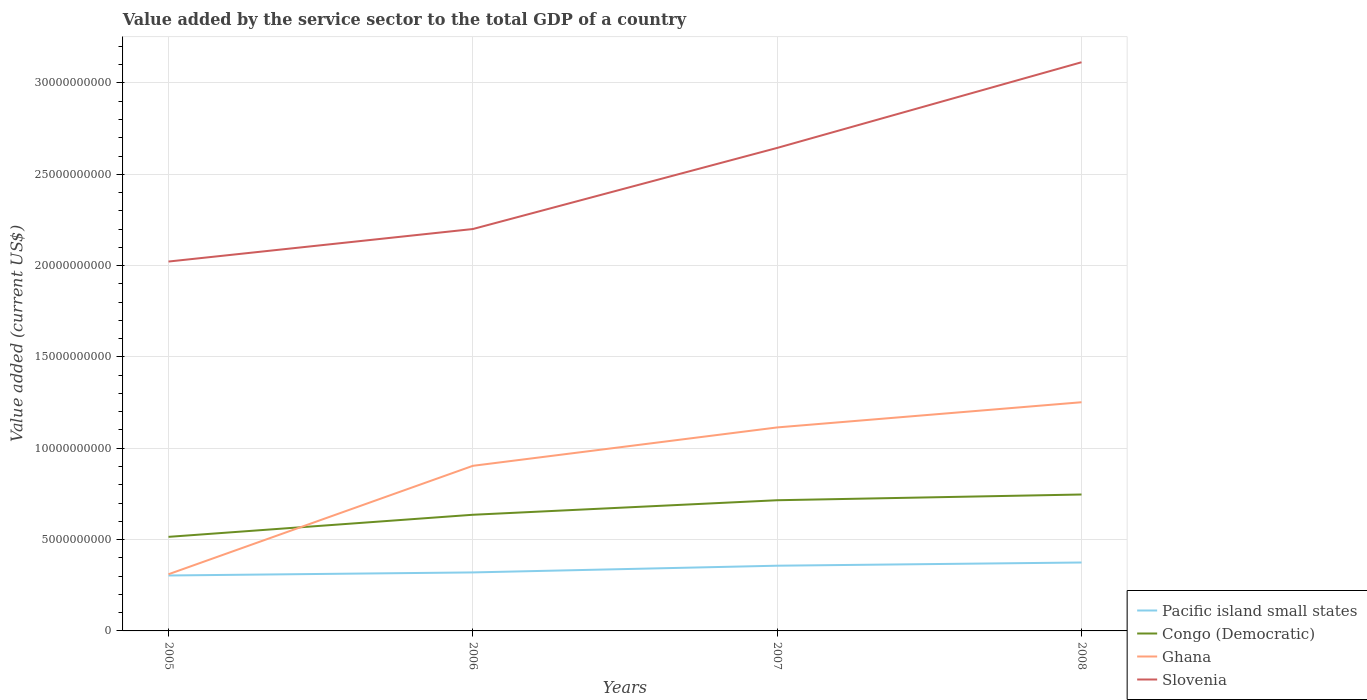Is the number of lines equal to the number of legend labels?
Your response must be concise. Yes. Across all years, what is the maximum value added by the service sector to the total GDP in Congo (Democratic)?
Ensure brevity in your answer.  5.15e+09. In which year was the value added by the service sector to the total GDP in Ghana maximum?
Provide a short and direct response. 2005. What is the total value added by the service sector to the total GDP in Pacific island small states in the graph?
Offer a terse response. -3.68e+08. What is the difference between the highest and the second highest value added by the service sector to the total GDP in Ghana?
Your answer should be compact. 9.42e+09. Is the value added by the service sector to the total GDP in Congo (Democratic) strictly greater than the value added by the service sector to the total GDP in Pacific island small states over the years?
Your response must be concise. No. How many years are there in the graph?
Ensure brevity in your answer.  4. Are the values on the major ticks of Y-axis written in scientific E-notation?
Make the answer very short. No. Does the graph contain any zero values?
Provide a short and direct response. No. Does the graph contain grids?
Offer a terse response. Yes. Where does the legend appear in the graph?
Ensure brevity in your answer.  Bottom right. How many legend labels are there?
Keep it short and to the point. 4. How are the legend labels stacked?
Your response must be concise. Vertical. What is the title of the graph?
Your answer should be compact. Value added by the service sector to the total GDP of a country. Does "Jamaica" appear as one of the legend labels in the graph?
Give a very brief answer. No. What is the label or title of the X-axis?
Give a very brief answer. Years. What is the label or title of the Y-axis?
Keep it short and to the point. Value added (current US$). What is the Value added (current US$) in Pacific island small states in 2005?
Offer a very short reply. 3.03e+09. What is the Value added (current US$) of Congo (Democratic) in 2005?
Make the answer very short. 5.15e+09. What is the Value added (current US$) in Ghana in 2005?
Offer a terse response. 3.10e+09. What is the Value added (current US$) of Slovenia in 2005?
Offer a very short reply. 2.02e+1. What is the Value added (current US$) in Pacific island small states in 2006?
Your answer should be very brief. 3.20e+09. What is the Value added (current US$) in Congo (Democratic) in 2006?
Keep it short and to the point. 6.36e+09. What is the Value added (current US$) of Ghana in 2006?
Your answer should be compact. 9.04e+09. What is the Value added (current US$) of Slovenia in 2006?
Ensure brevity in your answer.  2.20e+1. What is the Value added (current US$) of Pacific island small states in 2007?
Offer a terse response. 3.57e+09. What is the Value added (current US$) of Congo (Democratic) in 2007?
Provide a succinct answer. 7.15e+09. What is the Value added (current US$) in Ghana in 2007?
Give a very brief answer. 1.11e+1. What is the Value added (current US$) in Slovenia in 2007?
Ensure brevity in your answer.  2.64e+1. What is the Value added (current US$) in Pacific island small states in 2008?
Provide a short and direct response. 3.75e+09. What is the Value added (current US$) in Congo (Democratic) in 2008?
Your response must be concise. 7.47e+09. What is the Value added (current US$) in Ghana in 2008?
Provide a succinct answer. 1.25e+1. What is the Value added (current US$) of Slovenia in 2008?
Your answer should be compact. 3.11e+1. Across all years, what is the maximum Value added (current US$) of Pacific island small states?
Ensure brevity in your answer.  3.75e+09. Across all years, what is the maximum Value added (current US$) of Congo (Democratic)?
Offer a very short reply. 7.47e+09. Across all years, what is the maximum Value added (current US$) of Ghana?
Offer a very short reply. 1.25e+1. Across all years, what is the maximum Value added (current US$) of Slovenia?
Keep it short and to the point. 3.11e+1. Across all years, what is the minimum Value added (current US$) of Pacific island small states?
Make the answer very short. 3.03e+09. Across all years, what is the minimum Value added (current US$) of Congo (Democratic)?
Give a very brief answer. 5.15e+09. Across all years, what is the minimum Value added (current US$) in Ghana?
Your response must be concise. 3.10e+09. Across all years, what is the minimum Value added (current US$) of Slovenia?
Provide a succinct answer. 2.02e+1. What is the total Value added (current US$) of Pacific island small states in the graph?
Ensure brevity in your answer.  1.36e+1. What is the total Value added (current US$) of Congo (Democratic) in the graph?
Ensure brevity in your answer.  2.61e+1. What is the total Value added (current US$) in Ghana in the graph?
Make the answer very short. 3.58e+1. What is the total Value added (current US$) of Slovenia in the graph?
Your answer should be very brief. 9.98e+1. What is the difference between the Value added (current US$) in Pacific island small states in 2005 and that in 2006?
Provide a short and direct response. -1.68e+08. What is the difference between the Value added (current US$) in Congo (Democratic) in 2005 and that in 2006?
Provide a succinct answer. -1.21e+09. What is the difference between the Value added (current US$) in Ghana in 2005 and that in 2006?
Ensure brevity in your answer.  -5.94e+09. What is the difference between the Value added (current US$) in Slovenia in 2005 and that in 2006?
Offer a terse response. -1.78e+09. What is the difference between the Value added (current US$) of Pacific island small states in 2005 and that in 2007?
Your answer should be compact. -5.36e+08. What is the difference between the Value added (current US$) of Congo (Democratic) in 2005 and that in 2007?
Make the answer very short. -2.00e+09. What is the difference between the Value added (current US$) of Ghana in 2005 and that in 2007?
Make the answer very short. -8.04e+09. What is the difference between the Value added (current US$) of Slovenia in 2005 and that in 2007?
Offer a very short reply. -6.22e+09. What is the difference between the Value added (current US$) in Pacific island small states in 2005 and that in 2008?
Make the answer very short. -7.11e+08. What is the difference between the Value added (current US$) of Congo (Democratic) in 2005 and that in 2008?
Your answer should be compact. -2.32e+09. What is the difference between the Value added (current US$) in Ghana in 2005 and that in 2008?
Provide a short and direct response. -9.42e+09. What is the difference between the Value added (current US$) in Slovenia in 2005 and that in 2008?
Provide a short and direct response. -1.09e+1. What is the difference between the Value added (current US$) in Pacific island small states in 2006 and that in 2007?
Give a very brief answer. -3.68e+08. What is the difference between the Value added (current US$) in Congo (Democratic) in 2006 and that in 2007?
Ensure brevity in your answer.  -7.95e+08. What is the difference between the Value added (current US$) of Ghana in 2006 and that in 2007?
Provide a short and direct response. -2.10e+09. What is the difference between the Value added (current US$) of Slovenia in 2006 and that in 2007?
Your answer should be compact. -4.44e+09. What is the difference between the Value added (current US$) of Pacific island small states in 2006 and that in 2008?
Offer a terse response. -5.43e+08. What is the difference between the Value added (current US$) in Congo (Democratic) in 2006 and that in 2008?
Give a very brief answer. -1.11e+09. What is the difference between the Value added (current US$) in Ghana in 2006 and that in 2008?
Give a very brief answer. -3.48e+09. What is the difference between the Value added (current US$) in Slovenia in 2006 and that in 2008?
Offer a terse response. -9.13e+09. What is the difference between the Value added (current US$) of Pacific island small states in 2007 and that in 2008?
Your answer should be compact. -1.75e+08. What is the difference between the Value added (current US$) of Congo (Democratic) in 2007 and that in 2008?
Make the answer very short. -3.14e+08. What is the difference between the Value added (current US$) of Ghana in 2007 and that in 2008?
Give a very brief answer. -1.38e+09. What is the difference between the Value added (current US$) of Slovenia in 2007 and that in 2008?
Your answer should be very brief. -4.69e+09. What is the difference between the Value added (current US$) in Pacific island small states in 2005 and the Value added (current US$) in Congo (Democratic) in 2006?
Make the answer very short. -3.32e+09. What is the difference between the Value added (current US$) of Pacific island small states in 2005 and the Value added (current US$) of Ghana in 2006?
Provide a succinct answer. -6.00e+09. What is the difference between the Value added (current US$) in Pacific island small states in 2005 and the Value added (current US$) in Slovenia in 2006?
Your answer should be compact. -1.90e+1. What is the difference between the Value added (current US$) of Congo (Democratic) in 2005 and the Value added (current US$) of Ghana in 2006?
Keep it short and to the point. -3.89e+09. What is the difference between the Value added (current US$) in Congo (Democratic) in 2005 and the Value added (current US$) in Slovenia in 2006?
Offer a very short reply. -1.69e+1. What is the difference between the Value added (current US$) of Ghana in 2005 and the Value added (current US$) of Slovenia in 2006?
Offer a very short reply. -1.89e+1. What is the difference between the Value added (current US$) in Pacific island small states in 2005 and the Value added (current US$) in Congo (Democratic) in 2007?
Your answer should be compact. -4.12e+09. What is the difference between the Value added (current US$) of Pacific island small states in 2005 and the Value added (current US$) of Ghana in 2007?
Your answer should be very brief. -8.11e+09. What is the difference between the Value added (current US$) of Pacific island small states in 2005 and the Value added (current US$) of Slovenia in 2007?
Offer a terse response. -2.34e+1. What is the difference between the Value added (current US$) in Congo (Democratic) in 2005 and the Value added (current US$) in Ghana in 2007?
Your response must be concise. -5.99e+09. What is the difference between the Value added (current US$) of Congo (Democratic) in 2005 and the Value added (current US$) of Slovenia in 2007?
Your answer should be very brief. -2.13e+1. What is the difference between the Value added (current US$) in Ghana in 2005 and the Value added (current US$) in Slovenia in 2007?
Offer a terse response. -2.33e+1. What is the difference between the Value added (current US$) in Pacific island small states in 2005 and the Value added (current US$) in Congo (Democratic) in 2008?
Your answer should be compact. -4.43e+09. What is the difference between the Value added (current US$) of Pacific island small states in 2005 and the Value added (current US$) of Ghana in 2008?
Provide a short and direct response. -9.49e+09. What is the difference between the Value added (current US$) of Pacific island small states in 2005 and the Value added (current US$) of Slovenia in 2008?
Make the answer very short. -2.81e+1. What is the difference between the Value added (current US$) of Congo (Democratic) in 2005 and the Value added (current US$) of Ghana in 2008?
Keep it short and to the point. -7.37e+09. What is the difference between the Value added (current US$) in Congo (Democratic) in 2005 and the Value added (current US$) in Slovenia in 2008?
Give a very brief answer. -2.60e+1. What is the difference between the Value added (current US$) of Ghana in 2005 and the Value added (current US$) of Slovenia in 2008?
Give a very brief answer. -2.80e+1. What is the difference between the Value added (current US$) of Pacific island small states in 2006 and the Value added (current US$) of Congo (Democratic) in 2007?
Keep it short and to the point. -3.95e+09. What is the difference between the Value added (current US$) of Pacific island small states in 2006 and the Value added (current US$) of Ghana in 2007?
Your answer should be very brief. -7.94e+09. What is the difference between the Value added (current US$) of Pacific island small states in 2006 and the Value added (current US$) of Slovenia in 2007?
Ensure brevity in your answer.  -2.32e+1. What is the difference between the Value added (current US$) in Congo (Democratic) in 2006 and the Value added (current US$) in Ghana in 2007?
Your answer should be very brief. -4.78e+09. What is the difference between the Value added (current US$) in Congo (Democratic) in 2006 and the Value added (current US$) in Slovenia in 2007?
Your answer should be very brief. -2.01e+1. What is the difference between the Value added (current US$) in Ghana in 2006 and the Value added (current US$) in Slovenia in 2007?
Ensure brevity in your answer.  -1.74e+1. What is the difference between the Value added (current US$) in Pacific island small states in 2006 and the Value added (current US$) in Congo (Democratic) in 2008?
Ensure brevity in your answer.  -4.27e+09. What is the difference between the Value added (current US$) in Pacific island small states in 2006 and the Value added (current US$) in Ghana in 2008?
Your answer should be compact. -9.32e+09. What is the difference between the Value added (current US$) in Pacific island small states in 2006 and the Value added (current US$) in Slovenia in 2008?
Your answer should be compact. -2.79e+1. What is the difference between the Value added (current US$) in Congo (Democratic) in 2006 and the Value added (current US$) in Ghana in 2008?
Offer a terse response. -6.16e+09. What is the difference between the Value added (current US$) of Congo (Democratic) in 2006 and the Value added (current US$) of Slovenia in 2008?
Your answer should be very brief. -2.48e+1. What is the difference between the Value added (current US$) of Ghana in 2006 and the Value added (current US$) of Slovenia in 2008?
Provide a short and direct response. -2.21e+1. What is the difference between the Value added (current US$) in Pacific island small states in 2007 and the Value added (current US$) in Congo (Democratic) in 2008?
Your answer should be compact. -3.90e+09. What is the difference between the Value added (current US$) of Pacific island small states in 2007 and the Value added (current US$) of Ghana in 2008?
Your response must be concise. -8.95e+09. What is the difference between the Value added (current US$) in Pacific island small states in 2007 and the Value added (current US$) in Slovenia in 2008?
Your answer should be compact. -2.76e+1. What is the difference between the Value added (current US$) of Congo (Democratic) in 2007 and the Value added (current US$) of Ghana in 2008?
Provide a succinct answer. -5.37e+09. What is the difference between the Value added (current US$) of Congo (Democratic) in 2007 and the Value added (current US$) of Slovenia in 2008?
Provide a short and direct response. -2.40e+1. What is the difference between the Value added (current US$) in Ghana in 2007 and the Value added (current US$) in Slovenia in 2008?
Offer a terse response. -2.00e+1. What is the average Value added (current US$) of Pacific island small states per year?
Your answer should be very brief. 3.39e+09. What is the average Value added (current US$) of Congo (Democratic) per year?
Your answer should be compact. 6.53e+09. What is the average Value added (current US$) of Ghana per year?
Ensure brevity in your answer.  8.95e+09. What is the average Value added (current US$) in Slovenia per year?
Keep it short and to the point. 2.50e+1. In the year 2005, what is the difference between the Value added (current US$) in Pacific island small states and Value added (current US$) in Congo (Democratic)?
Your response must be concise. -2.12e+09. In the year 2005, what is the difference between the Value added (current US$) of Pacific island small states and Value added (current US$) of Ghana?
Your answer should be very brief. -6.82e+07. In the year 2005, what is the difference between the Value added (current US$) of Pacific island small states and Value added (current US$) of Slovenia?
Provide a short and direct response. -1.72e+1. In the year 2005, what is the difference between the Value added (current US$) in Congo (Democratic) and Value added (current US$) in Ghana?
Keep it short and to the point. 2.05e+09. In the year 2005, what is the difference between the Value added (current US$) of Congo (Democratic) and Value added (current US$) of Slovenia?
Provide a succinct answer. -1.51e+1. In the year 2005, what is the difference between the Value added (current US$) of Ghana and Value added (current US$) of Slovenia?
Ensure brevity in your answer.  -1.71e+1. In the year 2006, what is the difference between the Value added (current US$) of Pacific island small states and Value added (current US$) of Congo (Democratic)?
Keep it short and to the point. -3.16e+09. In the year 2006, what is the difference between the Value added (current US$) in Pacific island small states and Value added (current US$) in Ghana?
Ensure brevity in your answer.  -5.84e+09. In the year 2006, what is the difference between the Value added (current US$) of Pacific island small states and Value added (current US$) of Slovenia?
Offer a terse response. -1.88e+1. In the year 2006, what is the difference between the Value added (current US$) of Congo (Democratic) and Value added (current US$) of Ghana?
Offer a very short reply. -2.68e+09. In the year 2006, what is the difference between the Value added (current US$) of Congo (Democratic) and Value added (current US$) of Slovenia?
Ensure brevity in your answer.  -1.56e+1. In the year 2006, what is the difference between the Value added (current US$) of Ghana and Value added (current US$) of Slovenia?
Ensure brevity in your answer.  -1.30e+1. In the year 2007, what is the difference between the Value added (current US$) of Pacific island small states and Value added (current US$) of Congo (Democratic)?
Give a very brief answer. -3.58e+09. In the year 2007, what is the difference between the Value added (current US$) of Pacific island small states and Value added (current US$) of Ghana?
Your answer should be compact. -7.57e+09. In the year 2007, what is the difference between the Value added (current US$) in Pacific island small states and Value added (current US$) in Slovenia?
Ensure brevity in your answer.  -2.29e+1. In the year 2007, what is the difference between the Value added (current US$) in Congo (Democratic) and Value added (current US$) in Ghana?
Offer a terse response. -3.99e+09. In the year 2007, what is the difference between the Value added (current US$) of Congo (Democratic) and Value added (current US$) of Slovenia?
Your response must be concise. -1.93e+1. In the year 2007, what is the difference between the Value added (current US$) in Ghana and Value added (current US$) in Slovenia?
Provide a succinct answer. -1.53e+1. In the year 2008, what is the difference between the Value added (current US$) in Pacific island small states and Value added (current US$) in Congo (Democratic)?
Offer a very short reply. -3.72e+09. In the year 2008, what is the difference between the Value added (current US$) in Pacific island small states and Value added (current US$) in Ghana?
Make the answer very short. -8.77e+09. In the year 2008, what is the difference between the Value added (current US$) in Pacific island small states and Value added (current US$) in Slovenia?
Provide a succinct answer. -2.74e+1. In the year 2008, what is the difference between the Value added (current US$) in Congo (Democratic) and Value added (current US$) in Ghana?
Keep it short and to the point. -5.05e+09. In the year 2008, what is the difference between the Value added (current US$) in Congo (Democratic) and Value added (current US$) in Slovenia?
Your response must be concise. -2.37e+1. In the year 2008, what is the difference between the Value added (current US$) in Ghana and Value added (current US$) in Slovenia?
Your answer should be compact. -1.86e+1. What is the ratio of the Value added (current US$) of Pacific island small states in 2005 to that in 2006?
Offer a terse response. 0.95. What is the ratio of the Value added (current US$) of Congo (Democratic) in 2005 to that in 2006?
Offer a terse response. 0.81. What is the ratio of the Value added (current US$) in Ghana in 2005 to that in 2006?
Provide a short and direct response. 0.34. What is the ratio of the Value added (current US$) in Slovenia in 2005 to that in 2006?
Make the answer very short. 0.92. What is the ratio of the Value added (current US$) in Pacific island small states in 2005 to that in 2007?
Give a very brief answer. 0.85. What is the ratio of the Value added (current US$) in Congo (Democratic) in 2005 to that in 2007?
Your answer should be compact. 0.72. What is the ratio of the Value added (current US$) of Ghana in 2005 to that in 2007?
Offer a very short reply. 0.28. What is the ratio of the Value added (current US$) in Slovenia in 2005 to that in 2007?
Your answer should be very brief. 0.76. What is the ratio of the Value added (current US$) in Pacific island small states in 2005 to that in 2008?
Your answer should be compact. 0.81. What is the ratio of the Value added (current US$) of Congo (Democratic) in 2005 to that in 2008?
Make the answer very short. 0.69. What is the ratio of the Value added (current US$) in Ghana in 2005 to that in 2008?
Your answer should be very brief. 0.25. What is the ratio of the Value added (current US$) of Slovenia in 2005 to that in 2008?
Keep it short and to the point. 0.65. What is the ratio of the Value added (current US$) of Pacific island small states in 2006 to that in 2007?
Give a very brief answer. 0.9. What is the ratio of the Value added (current US$) in Congo (Democratic) in 2006 to that in 2007?
Offer a terse response. 0.89. What is the ratio of the Value added (current US$) of Ghana in 2006 to that in 2007?
Ensure brevity in your answer.  0.81. What is the ratio of the Value added (current US$) in Slovenia in 2006 to that in 2007?
Ensure brevity in your answer.  0.83. What is the ratio of the Value added (current US$) in Pacific island small states in 2006 to that in 2008?
Your answer should be very brief. 0.85. What is the ratio of the Value added (current US$) in Congo (Democratic) in 2006 to that in 2008?
Your answer should be very brief. 0.85. What is the ratio of the Value added (current US$) in Ghana in 2006 to that in 2008?
Provide a succinct answer. 0.72. What is the ratio of the Value added (current US$) in Slovenia in 2006 to that in 2008?
Give a very brief answer. 0.71. What is the ratio of the Value added (current US$) in Pacific island small states in 2007 to that in 2008?
Ensure brevity in your answer.  0.95. What is the ratio of the Value added (current US$) of Congo (Democratic) in 2007 to that in 2008?
Offer a very short reply. 0.96. What is the ratio of the Value added (current US$) in Ghana in 2007 to that in 2008?
Give a very brief answer. 0.89. What is the ratio of the Value added (current US$) of Slovenia in 2007 to that in 2008?
Ensure brevity in your answer.  0.85. What is the difference between the highest and the second highest Value added (current US$) of Pacific island small states?
Your answer should be very brief. 1.75e+08. What is the difference between the highest and the second highest Value added (current US$) of Congo (Democratic)?
Offer a very short reply. 3.14e+08. What is the difference between the highest and the second highest Value added (current US$) in Ghana?
Offer a very short reply. 1.38e+09. What is the difference between the highest and the second highest Value added (current US$) in Slovenia?
Keep it short and to the point. 4.69e+09. What is the difference between the highest and the lowest Value added (current US$) in Pacific island small states?
Your answer should be very brief. 7.11e+08. What is the difference between the highest and the lowest Value added (current US$) in Congo (Democratic)?
Provide a short and direct response. 2.32e+09. What is the difference between the highest and the lowest Value added (current US$) of Ghana?
Make the answer very short. 9.42e+09. What is the difference between the highest and the lowest Value added (current US$) in Slovenia?
Offer a very short reply. 1.09e+1. 